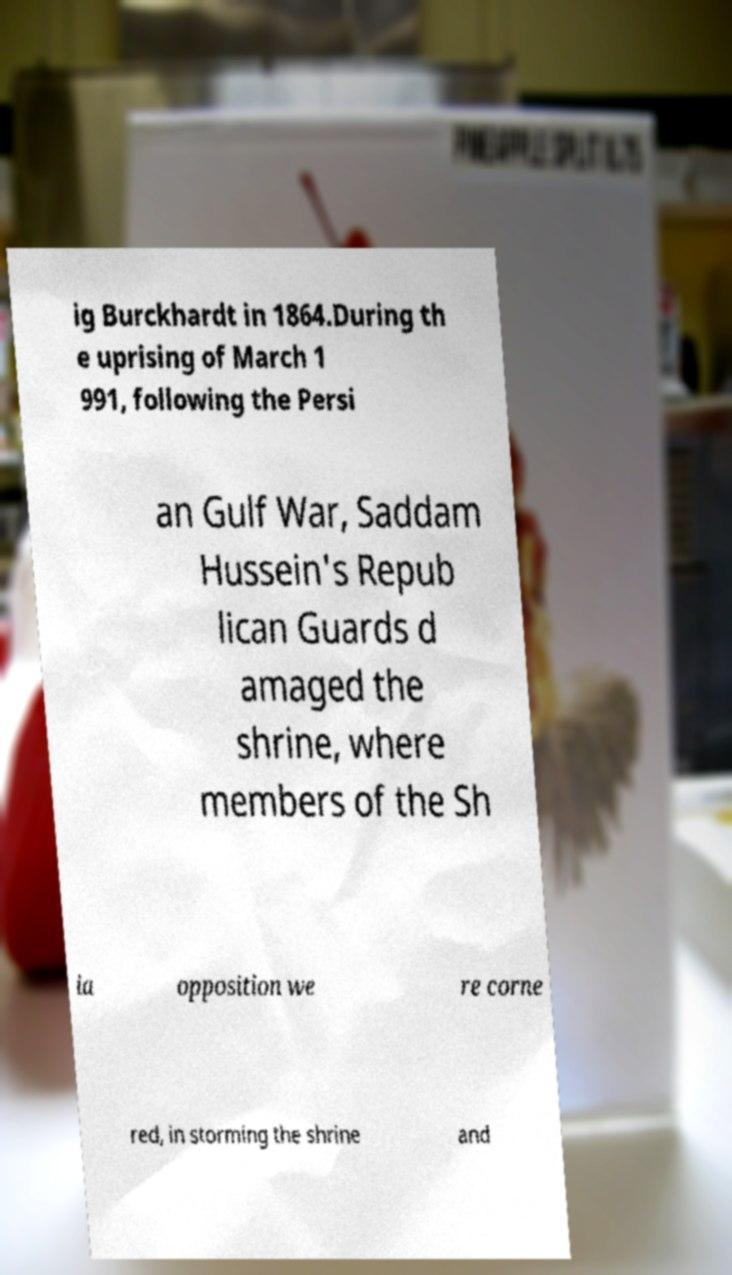What messages or text are displayed in this image? I need them in a readable, typed format. ig Burckhardt in 1864.During th e uprising of March 1 991, following the Persi an Gulf War, Saddam Hussein's Repub lican Guards d amaged the shrine, where members of the Sh ia opposition we re corne red, in storming the shrine and 